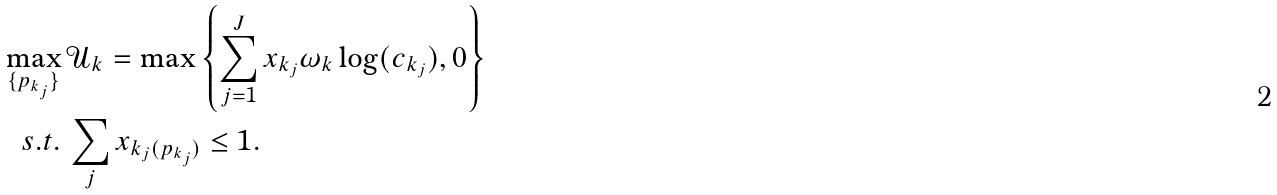Convert formula to latex. <formula><loc_0><loc_0><loc_500><loc_500>\max _ { \{ p _ { k _ { j } } \} } & \, \mathcal { U } _ { k } = \max \left \{ \sum _ { j = 1 } ^ { J } x _ { k _ { j } } \omega _ { k } \log ( c _ { k _ { j } } ) , 0 \right \} \\ s . t . & \, \sum _ { j } x _ { k _ { j } ( p _ { k _ { j } } ) } \leq 1 .</formula> 